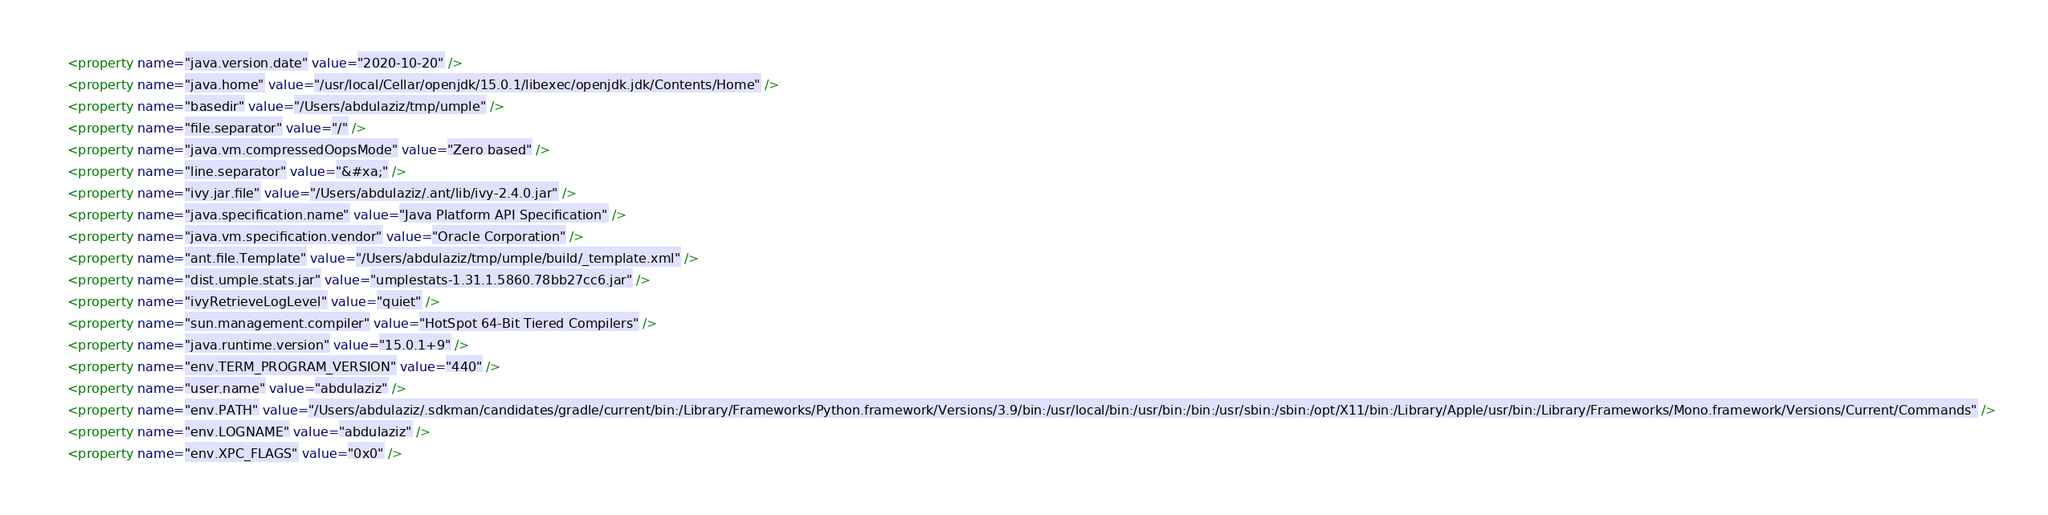Convert code to text. <code><loc_0><loc_0><loc_500><loc_500><_XML_>    <property name="java.version.date" value="2020-10-20" />
    <property name="java.home" value="/usr/local/Cellar/openjdk/15.0.1/libexec/openjdk.jdk/Contents/Home" />
    <property name="basedir" value="/Users/abdulaziz/tmp/umple" />
    <property name="file.separator" value="/" />
    <property name="java.vm.compressedOopsMode" value="Zero based" />
    <property name="line.separator" value="&#xa;" />
    <property name="ivy.jar.file" value="/Users/abdulaziz/.ant/lib/ivy-2.4.0.jar" />
    <property name="java.specification.name" value="Java Platform API Specification" />
    <property name="java.vm.specification.vendor" value="Oracle Corporation" />
    <property name="ant.file.Template" value="/Users/abdulaziz/tmp/umple/build/_template.xml" />
    <property name="dist.umple.stats.jar" value="umplestats-1.31.1.5860.78bb27cc6.jar" />
    <property name="ivyRetrieveLogLevel" value="quiet" />
    <property name="sun.management.compiler" value="HotSpot 64-Bit Tiered Compilers" />
    <property name="java.runtime.version" value="15.0.1+9" />
    <property name="env.TERM_PROGRAM_VERSION" value="440" />
    <property name="user.name" value="abdulaziz" />
    <property name="env.PATH" value="/Users/abdulaziz/.sdkman/candidates/gradle/current/bin:/Library/Frameworks/Python.framework/Versions/3.9/bin:/usr/local/bin:/usr/bin:/bin:/usr/sbin:/sbin:/opt/X11/bin:/Library/Apple/usr/bin:/Library/Frameworks/Mono.framework/Versions/Current/Commands" />
    <property name="env.LOGNAME" value="abdulaziz" />
    <property name="env.XPC_FLAGS" value="0x0" /></code> 